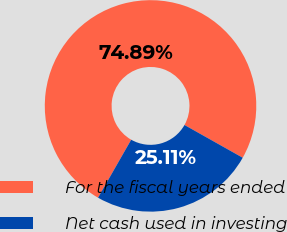<chart> <loc_0><loc_0><loc_500><loc_500><pie_chart><fcel>For the fiscal years ended<fcel>Net cash used in investing<nl><fcel>74.89%<fcel>25.11%<nl></chart> 